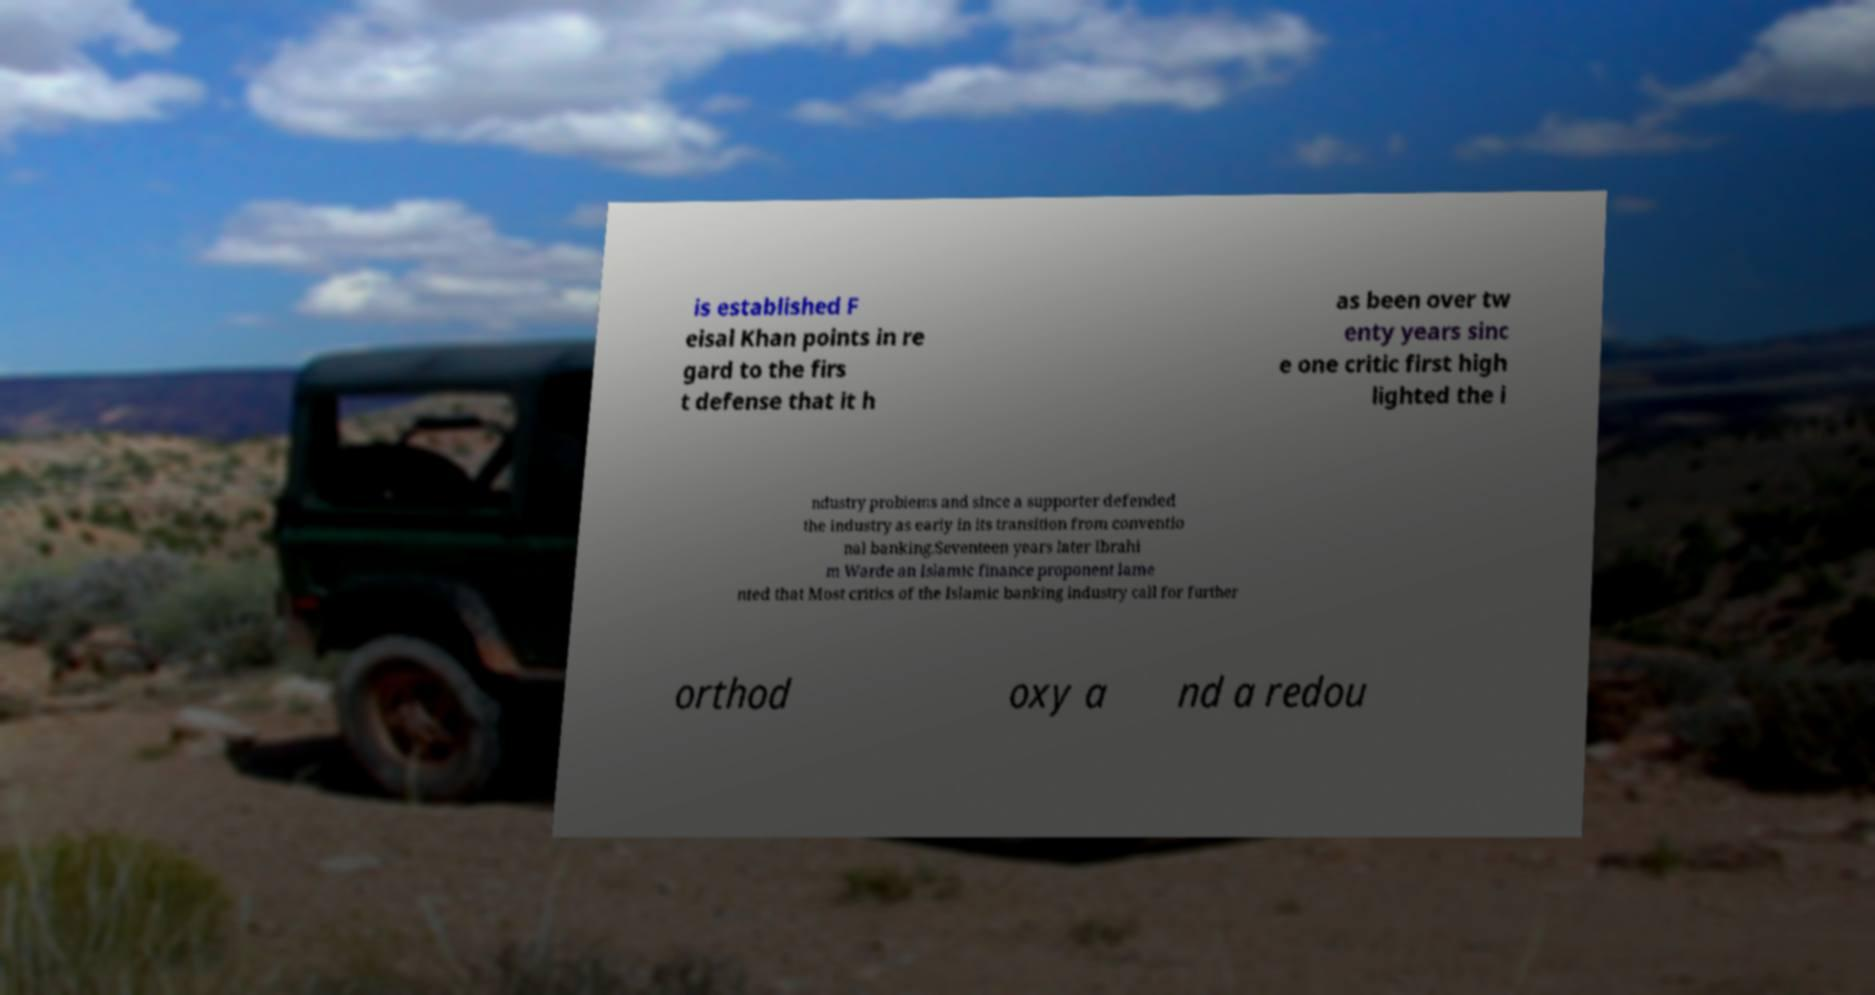Could you assist in decoding the text presented in this image and type it out clearly? is established F eisal Khan points in re gard to the firs t defense that it h as been over tw enty years sinc e one critic first high lighted the i ndustry problems and since a supporter defended the industry as early in its transition from conventio nal banking.Seventeen years later Ibrahi m Warde an Islamic finance proponent lame nted that Most critics of the Islamic banking industry call for further orthod oxy a nd a redou 